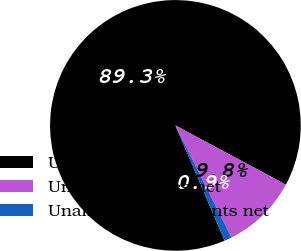Convert chart to OTSL. <chart><loc_0><loc_0><loc_500><loc_500><pie_chart><fcel>Unearned income<fcel>Unamortized fees net<fcel>Unamortized discounts net<nl><fcel>89.26%<fcel>9.79%<fcel>0.95%<nl></chart> 